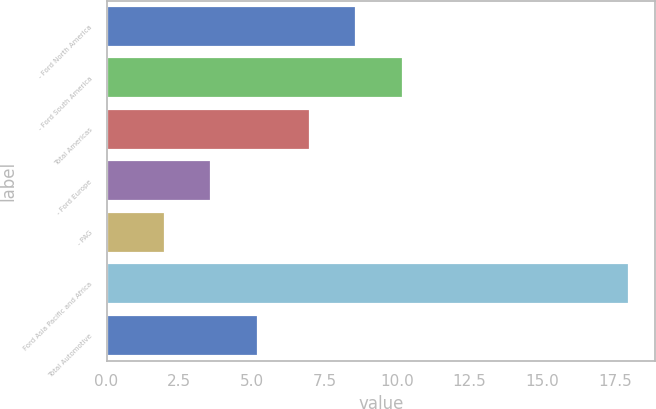<chart> <loc_0><loc_0><loc_500><loc_500><bar_chart><fcel>- Ford North America<fcel>- Ford South America<fcel>Total Americas<fcel>- Ford Europe<fcel>- PAG<fcel>Ford Asia Pacific and Africa<fcel>Total Automotive<nl><fcel>8.6<fcel>10.2<fcel>7<fcel>3.6<fcel>2<fcel>18<fcel>5.2<nl></chart> 